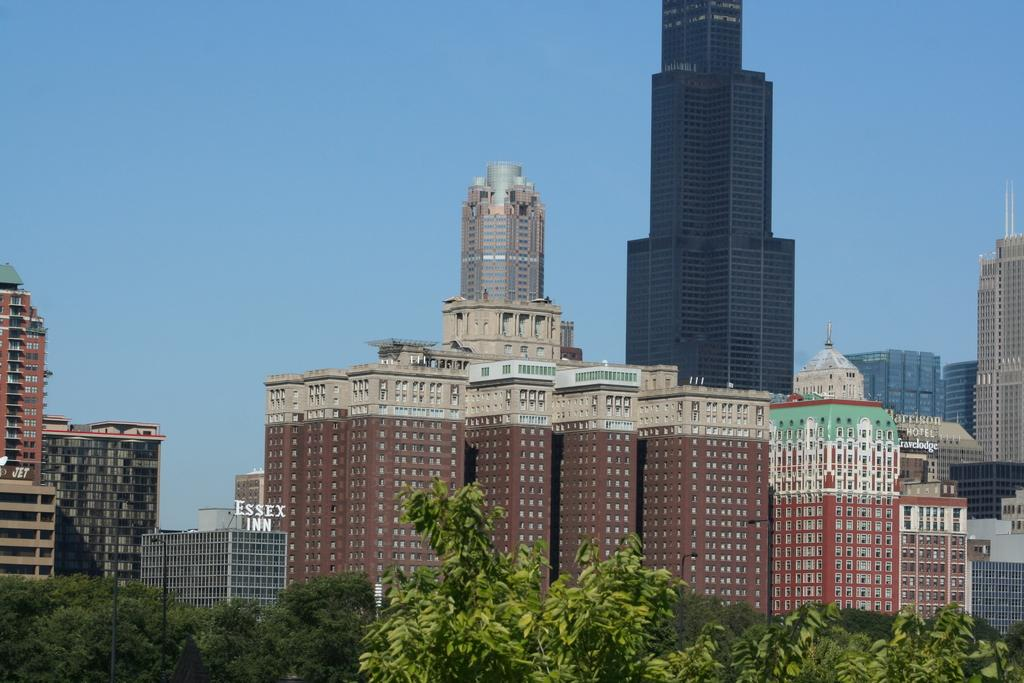What type of vegetation can be seen in the image? There are trees in the image. What is the color of the trees? The trees are green. What type of structures are present in the image? There are buildings in the image. What colors are the buildings? The buildings are in brown, cream, and gray colors. What is visible in the sky in the image? The sky is blue. Can you see a stream running through the trees in the image? There is no stream visible in the image; it only features trees and buildings. Are there any pigs present in the image? There are no pigs present in the image. 